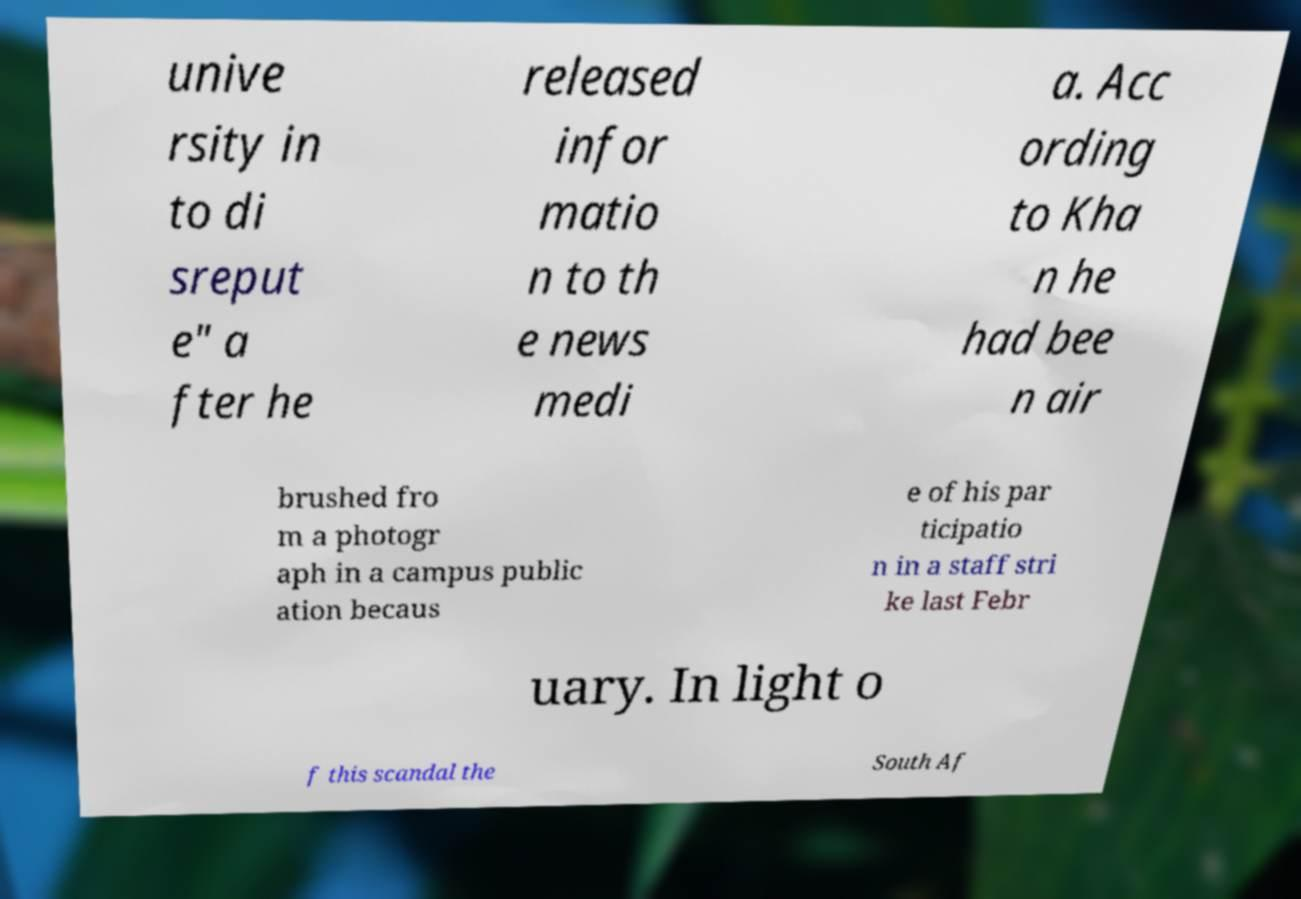Could you extract and type out the text from this image? unive rsity in to di sreput e" a fter he released infor matio n to th e news medi a. Acc ording to Kha n he had bee n air brushed fro m a photogr aph in a campus public ation becaus e of his par ticipatio n in a staff stri ke last Febr uary. In light o f this scandal the South Af 